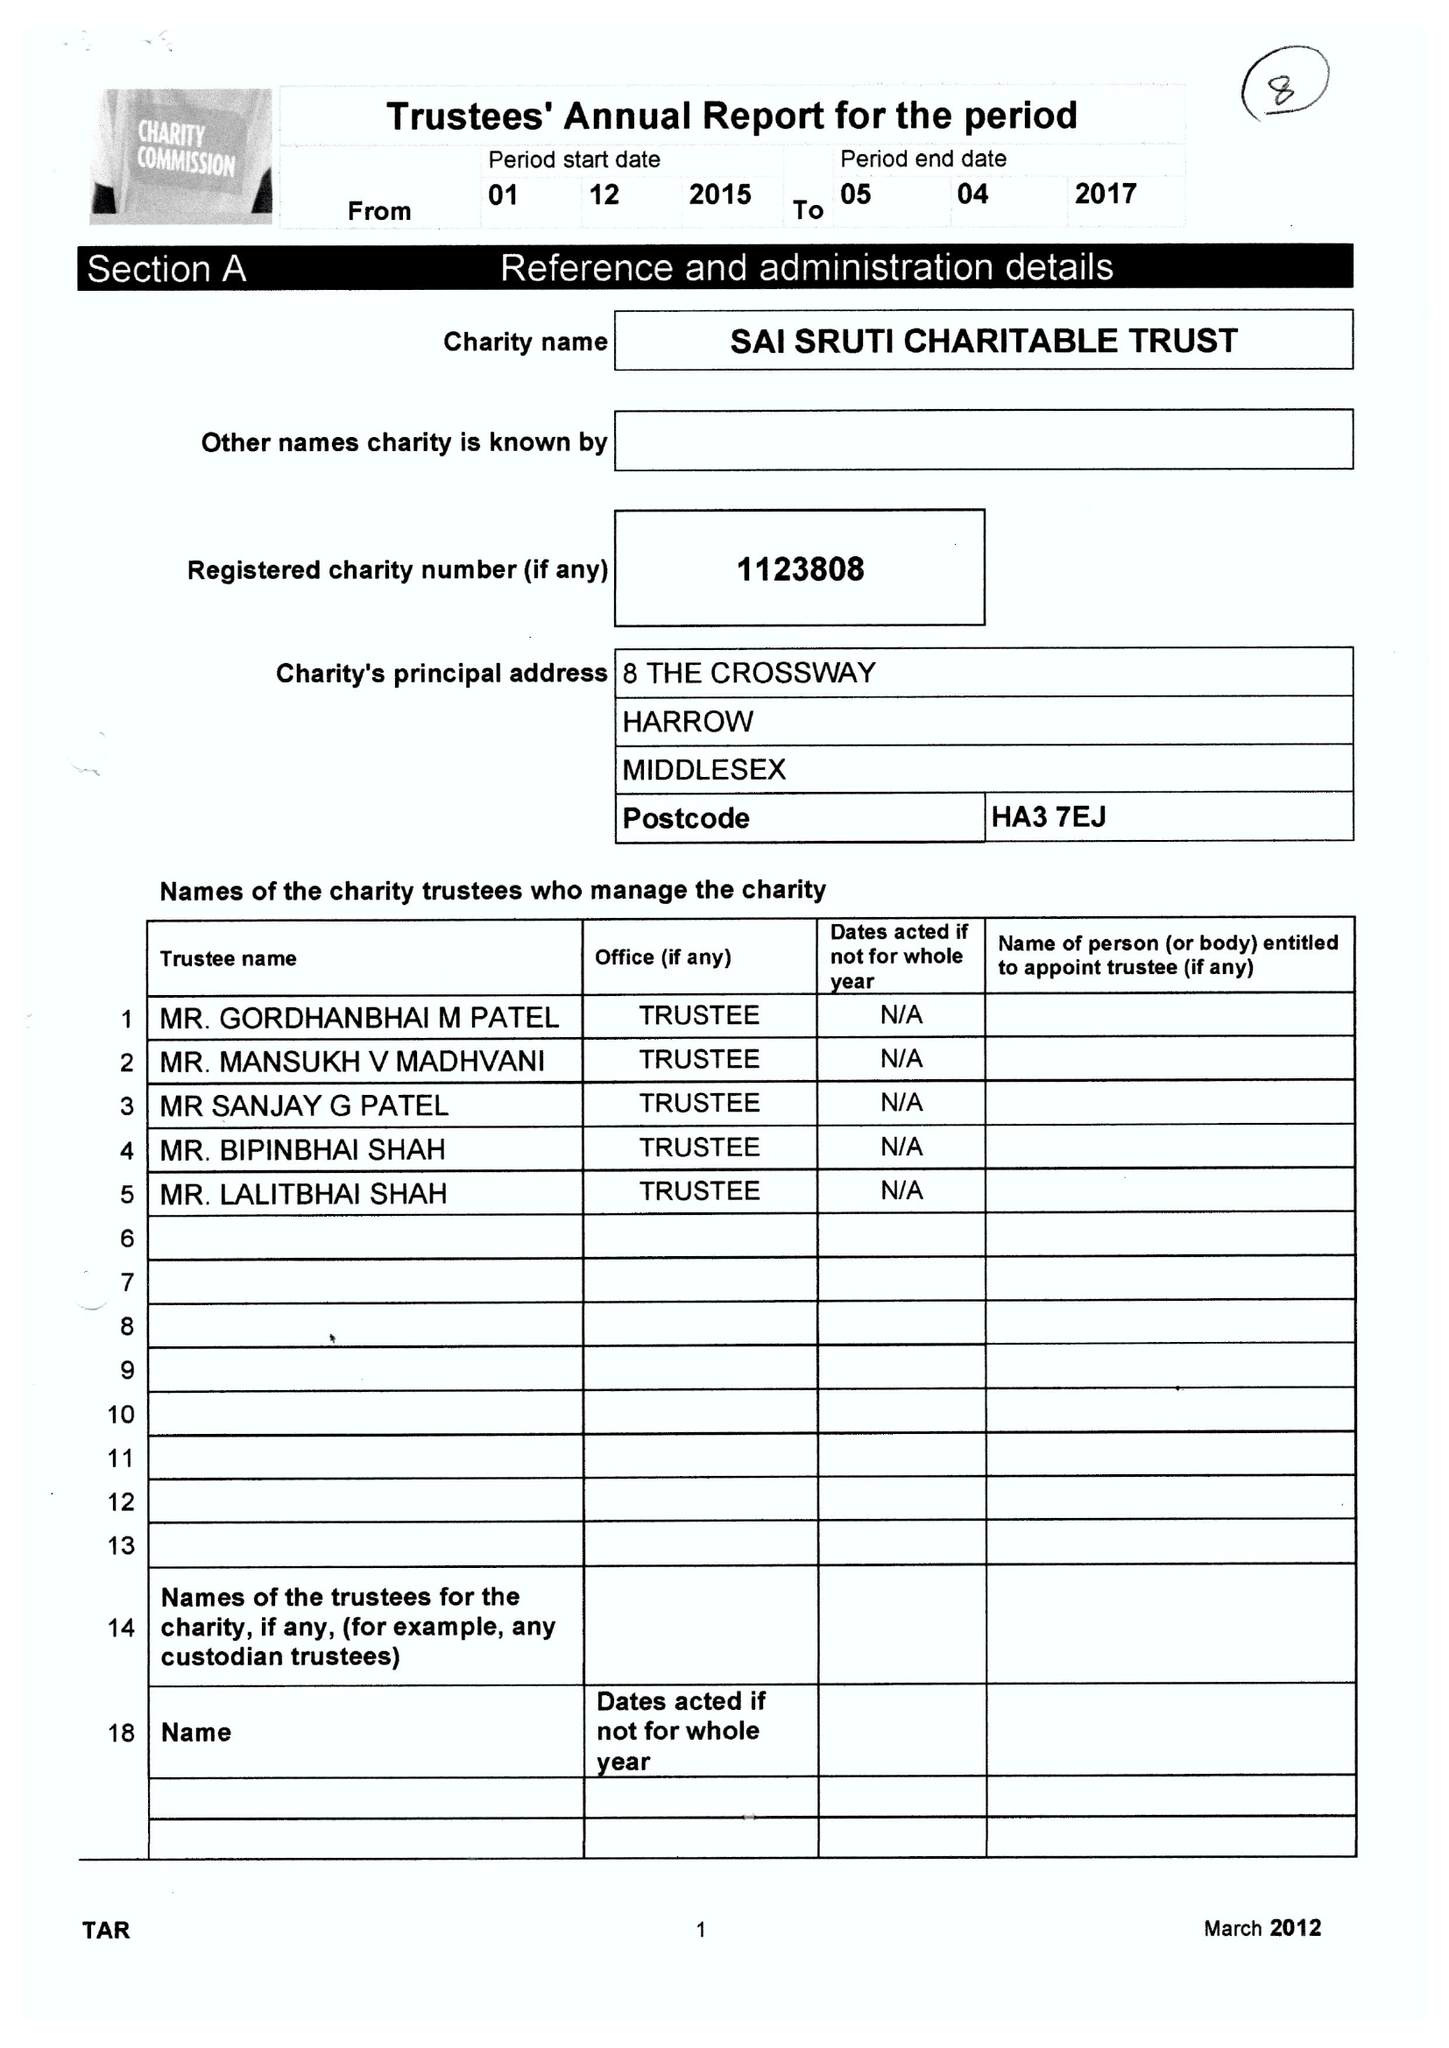What is the value for the charity_number?
Answer the question using a single word or phrase. 1123808 